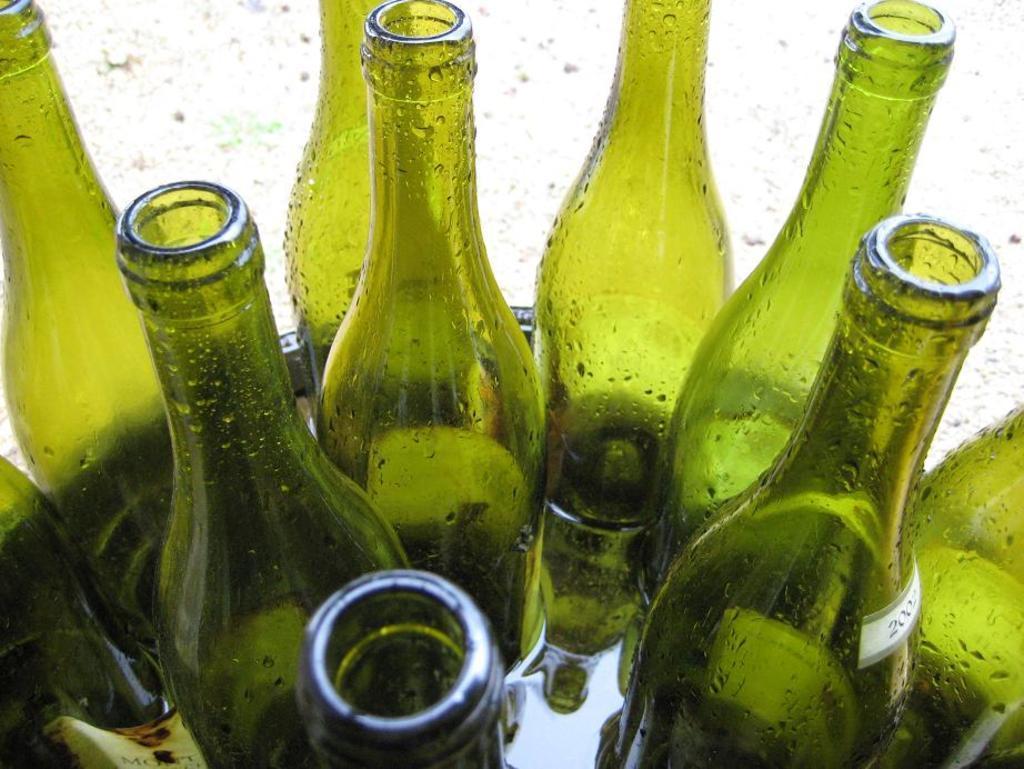Could you give a brief overview of what you see in this image? There are many green bottles are kept in the water in a bowl. 